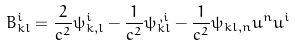Convert formula to latex. <formula><loc_0><loc_0><loc_500><loc_500>B _ { k l } ^ { i } = \frac { 2 } { c ^ { 2 } } \psi _ { k , l } ^ { i } - \frac { 1 } { c ^ { 2 } } \psi _ { k l } ^ { \, , i } - \frac { 1 } { c ^ { 2 } } \psi _ { k l , n } u ^ { n } u ^ { i }</formula> 